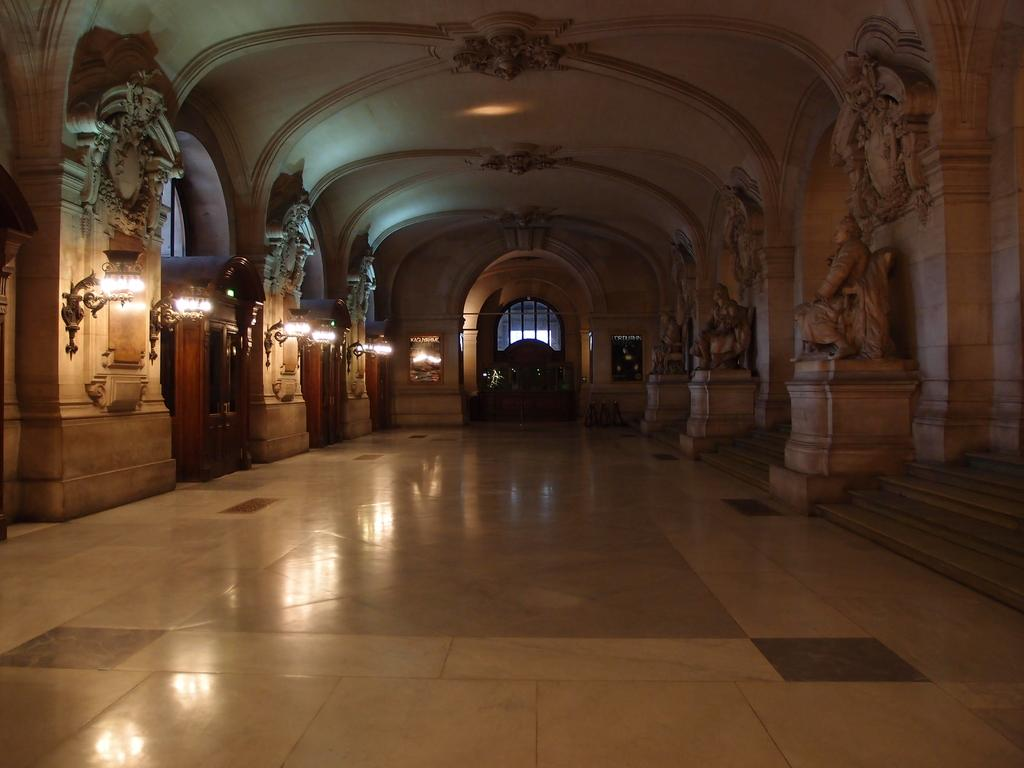Where was the image taken? The image was taken in a hall. What can be seen in the hall? There are sculptures and lights visible in the image. What architectural feature is present in the hall? There is an arch in the image. Is there any source of natural light in the hall? Yes, there is a window in the image. What type of loaf is being sliced on the table in the image? There is no table or loaf present in the image; it features a hall with sculptures, lights, an arch, and a window. Can you tell me how many calculators are visible on the sculptures in the image? There are no calculators present on the sculptures in the image. 